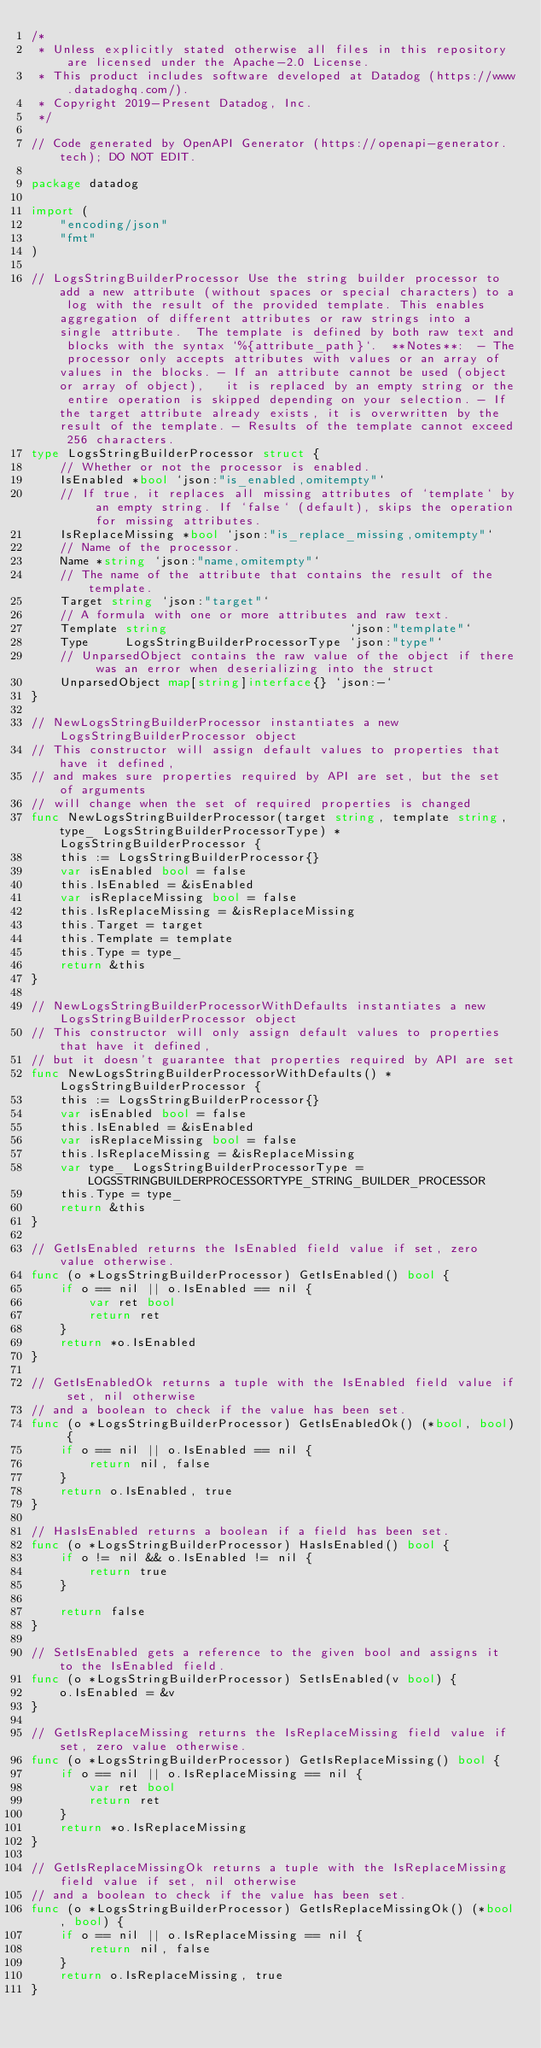Convert code to text. <code><loc_0><loc_0><loc_500><loc_500><_Go_>/*
 * Unless explicitly stated otherwise all files in this repository are licensed under the Apache-2.0 License.
 * This product includes software developed at Datadog (https://www.datadoghq.com/).
 * Copyright 2019-Present Datadog, Inc.
 */

// Code generated by OpenAPI Generator (https://openapi-generator.tech); DO NOT EDIT.

package datadog

import (
	"encoding/json"
	"fmt"
)

// LogsStringBuilderProcessor Use the string builder processor to add a new attribute (without spaces or special characters) to a log with the result of the provided template. This enables aggregation of different attributes or raw strings into a single attribute.  The template is defined by both raw text and blocks with the syntax `%{attribute_path}`.  **Notes**:  - The processor only accepts attributes with values or an array of values in the blocks. - If an attribute cannot be used (object or array of object),   it is replaced by an empty string or the entire operation is skipped depending on your selection. - If the target attribute already exists, it is overwritten by the result of the template. - Results of the template cannot exceed 256 characters.
type LogsStringBuilderProcessor struct {
	// Whether or not the processor is enabled.
	IsEnabled *bool `json:"is_enabled,omitempty"`
	// If true, it replaces all missing attributes of `template` by an empty string. If `false` (default), skips the operation for missing attributes.
	IsReplaceMissing *bool `json:"is_replace_missing,omitempty"`
	// Name of the processor.
	Name *string `json:"name,omitempty"`
	// The name of the attribute that contains the result of the template.
	Target string `json:"target"`
	// A formula with one or more attributes and raw text.
	Template string                         `json:"template"`
	Type     LogsStringBuilderProcessorType `json:"type"`
	// UnparsedObject contains the raw value of the object if there was an error when deserializing into the struct
	UnparsedObject map[string]interface{} `json:-`
}

// NewLogsStringBuilderProcessor instantiates a new LogsStringBuilderProcessor object
// This constructor will assign default values to properties that have it defined,
// and makes sure properties required by API are set, but the set of arguments
// will change when the set of required properties is changed
func NewLogsStringBuilderProcessor(target string, template string, type_ LogsStringBuilderProcessorType) *LogsStringBuilderProcessor {
	this := LogsStringBuilderProcessor{}
	var isEnabled bool = false
	this.IsEnabled = &isEnabled
	var isReplaceMissing bool = false
	this.IsReplaceMissing = &isReplaceMissing
	this.Target = target
	this.Template = template
	this.Type = type_
	return &this
}

// NewLogsStringBuilderProcessorWithDefaults instantiates a new LogsStringBuilderProcessor object
// This constructor will only assign default values to properties that have it defined,
// but it doesn't guarantee that properties required by API are set
func NewLogsStringBuilderProcessorWithDefaults() *LogsStringBuilderProcessor {
	this := LogsStringBuilderProcessor{}
	var isEnabled bool = false
	this.IsEnabled = &isEnabled
	var isReplaceMissing bool = false
	this.IsReplaceMissing = &isReplaceMissing
	var type_ LogsStringBuilderProcessorType = LOGSSTRINGBUILDERPROCESSORTYPE_STRING_BUILDER_PROCESSOR
	this.Type = type_
	return &this
}

// GetIsEnabled returns the IsEnabled field value if set, zero value otherwise.
func (o *LogsStringBuilderProcessor) GetIsEnabled() bool {
	if o == nil || o.IsEnabled == nil {
		var ret bool
		return ret
	}
	return *o.IsEnabled
}

// GetIsEnabledOk returns a tuple with the IsEnabled field value if set, nil otherwise
// and a boolean to check if the value has been set.
func (o *LogsStringBuilderProcessor) GetIsEnabledOk() (*bool, bool) {
	if o == nil || o.IsEnabled == nil {
		return nil, false
	}
	return o.IsEnabled, true
}

// HasIsEnabled returns a boolean if a field has been set.
func (o *LogsStringBuilderProcessor) HasIsEnabled() bool {
	if o != nil && o.IsEnabled != nil {
		return true
	}

	return false
}

// SetIsEnabled gets a reference to the given bool and assigns it to the IsEnabled field.
func (o *LogsStringBuilderProcessor) SetIsEnabled(v bool) {
	o.IsEnabled = &v
}

// GetIsReplaceMissing returns the IsReplaceMissing field value if set, zero value otherwise.
func (o *LogsStringBuilderProcessor) GetIsReplaceMissing() bool {
	if o == nil || o.IsReplaceMissing == nil {
		var ret bool
		return ret
	}
	return *o.IsReplaceMissing
}

// GetIsReplaceMissingOk returns a tuple with the IsReplaceMissing field value if set, nil otherwise
// and a boolean to check if the value has been set.
func (o *LogsStringBuilderProcessor) GetIsReplaceMissingOk() (*bool, bool) {
	if o == nil || o.IsReplaceMissing == nil {
		return nil, false
	}
	return o.IsReplaceMissing, true
}
</code> 